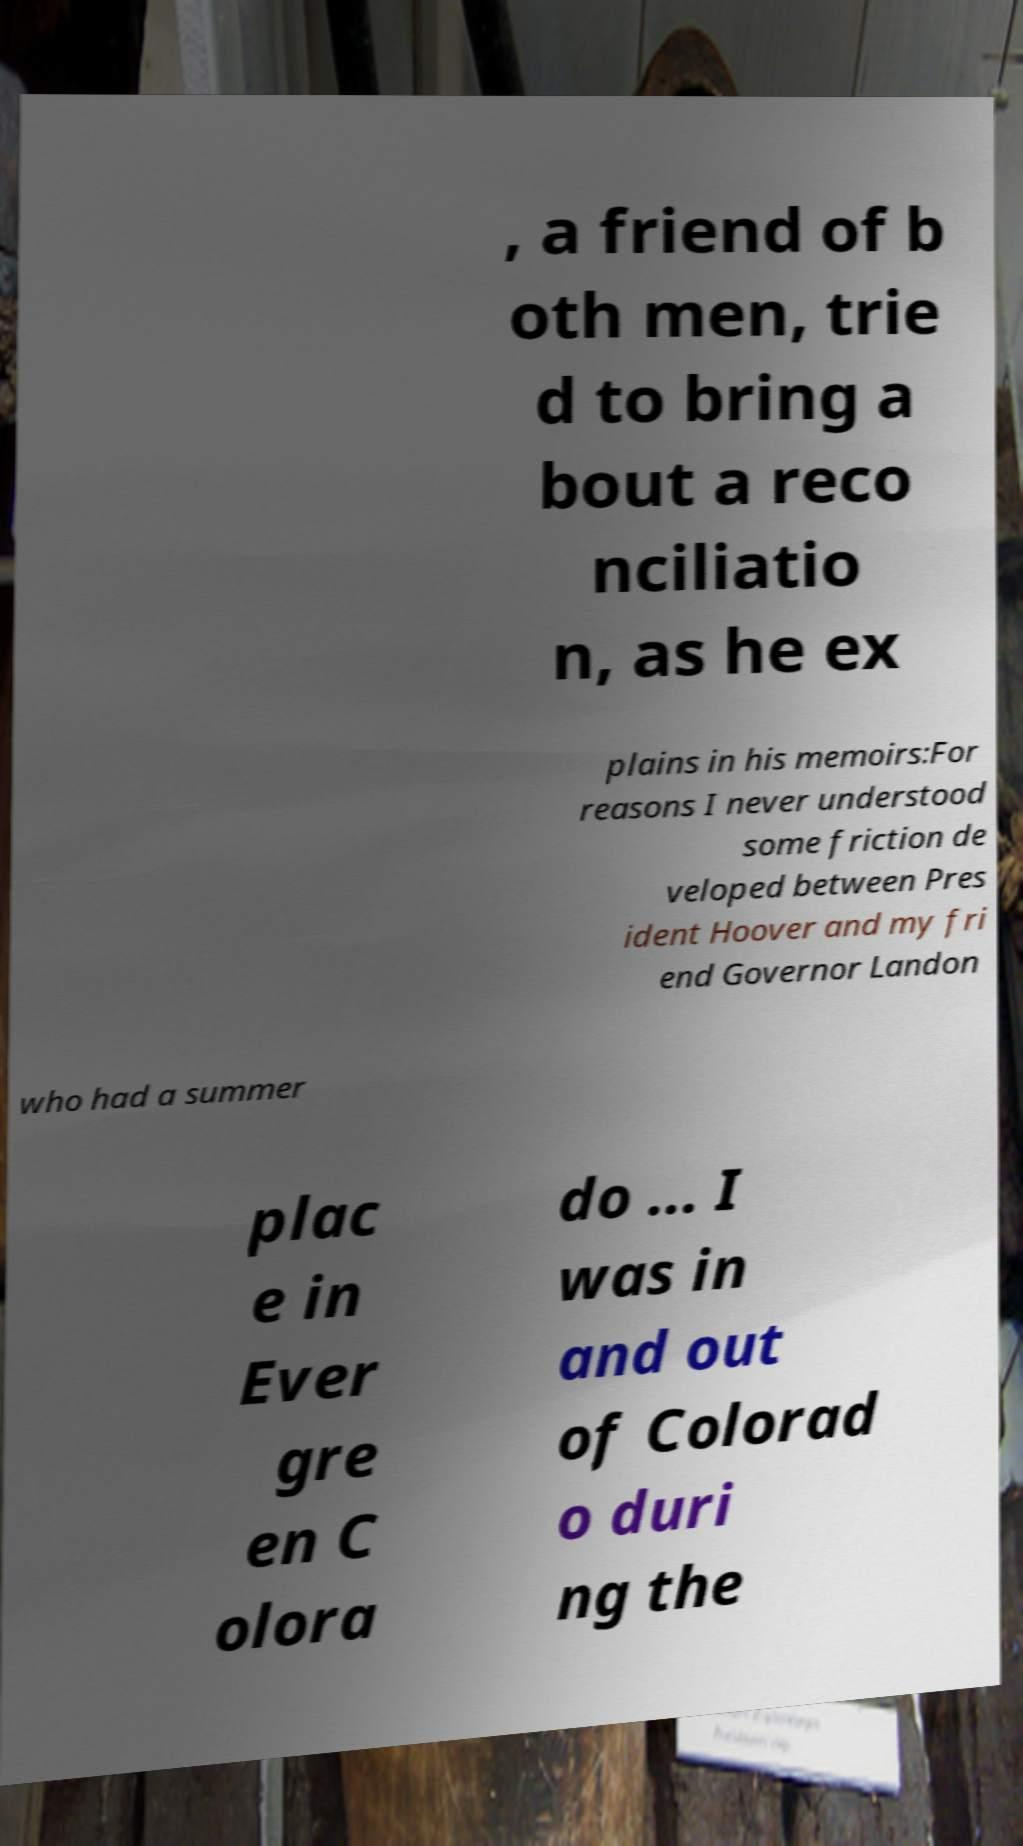Could you assist in decoding the text presented in this image and type it out clearly? , a friend of b oth men, trie d to bring a bout a reco nciliatio n, as he ex plains in his memoirs:For reasons I never understood some friction de veloped between Pres ident Hoover and my fri end Governor Landon who had a summer plac e in Ever gre en C olora do ... I was in and out of Colorad o duri ng the 